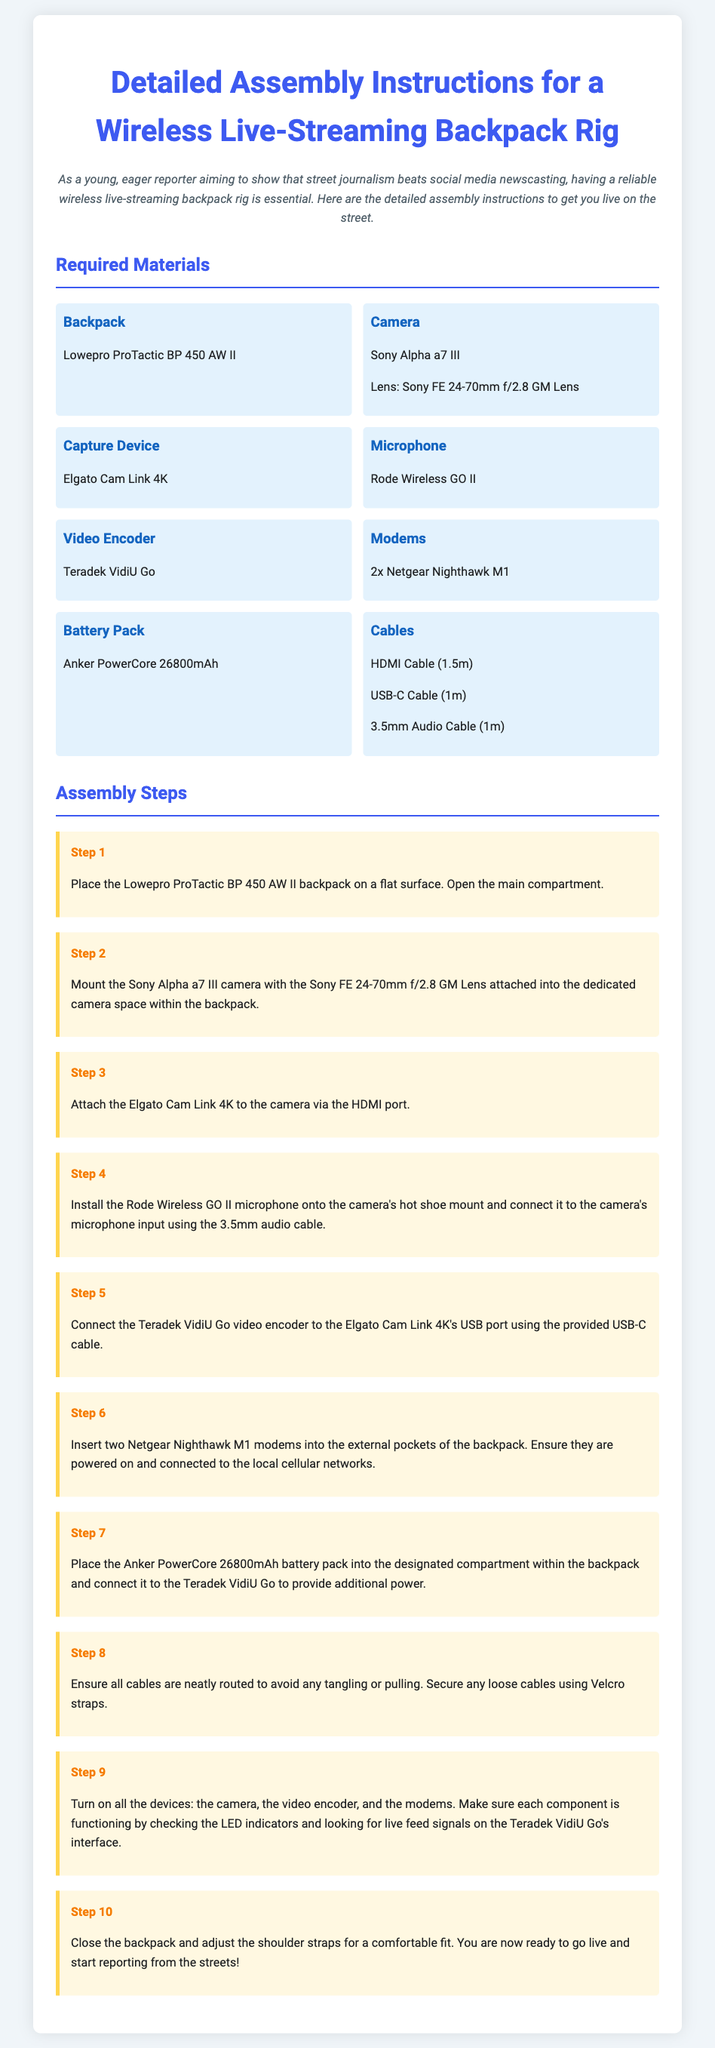What is the model of the backpack? The backpack model is specified in the materials list under "Backpack."
Answer: Lowepro ProTactic BP 450 AW II What device is used to capture video? The capture device is listed in the materials section, specifying its purpose.
Answer: Elgato Cam Link 4K How many modem units are required? The instructions state the number of modems needed in the materials section.
Answer: 2 Which microphone is used in the assembly? The microphone is detailed in the materials list, indicating its type and brand.
Answer: Rode Wireless GO II What is the first step in the assembly? The first instruction is clearly listed in the steps section of the document.
Answer: Place the Lowepro ProTactic BP 450 AW II backpack on a flat surface What should you do after placing the battery pack? This step involves connecting the battery pack as outlined in the assembly instructions.
Answer: Connect it to the Teradek VidiU Go to provide additional power What is the final step before going live? The last instruction in the assembly steps indicates the concluding action.
Answer: Close the backpack and adjust the shoulder straps for a comfortable fit Which cable is used to connect the Elgato Cam Link 4K to the camera? The specific cable type needed for this connection is mentioned in the assembly steps.
Answer: HDMI Cable How do you ensure all devices are functioning? The document outlines a check for functionality within the steps provided.
Answer: Check the LED indicators and look for live feed signals 